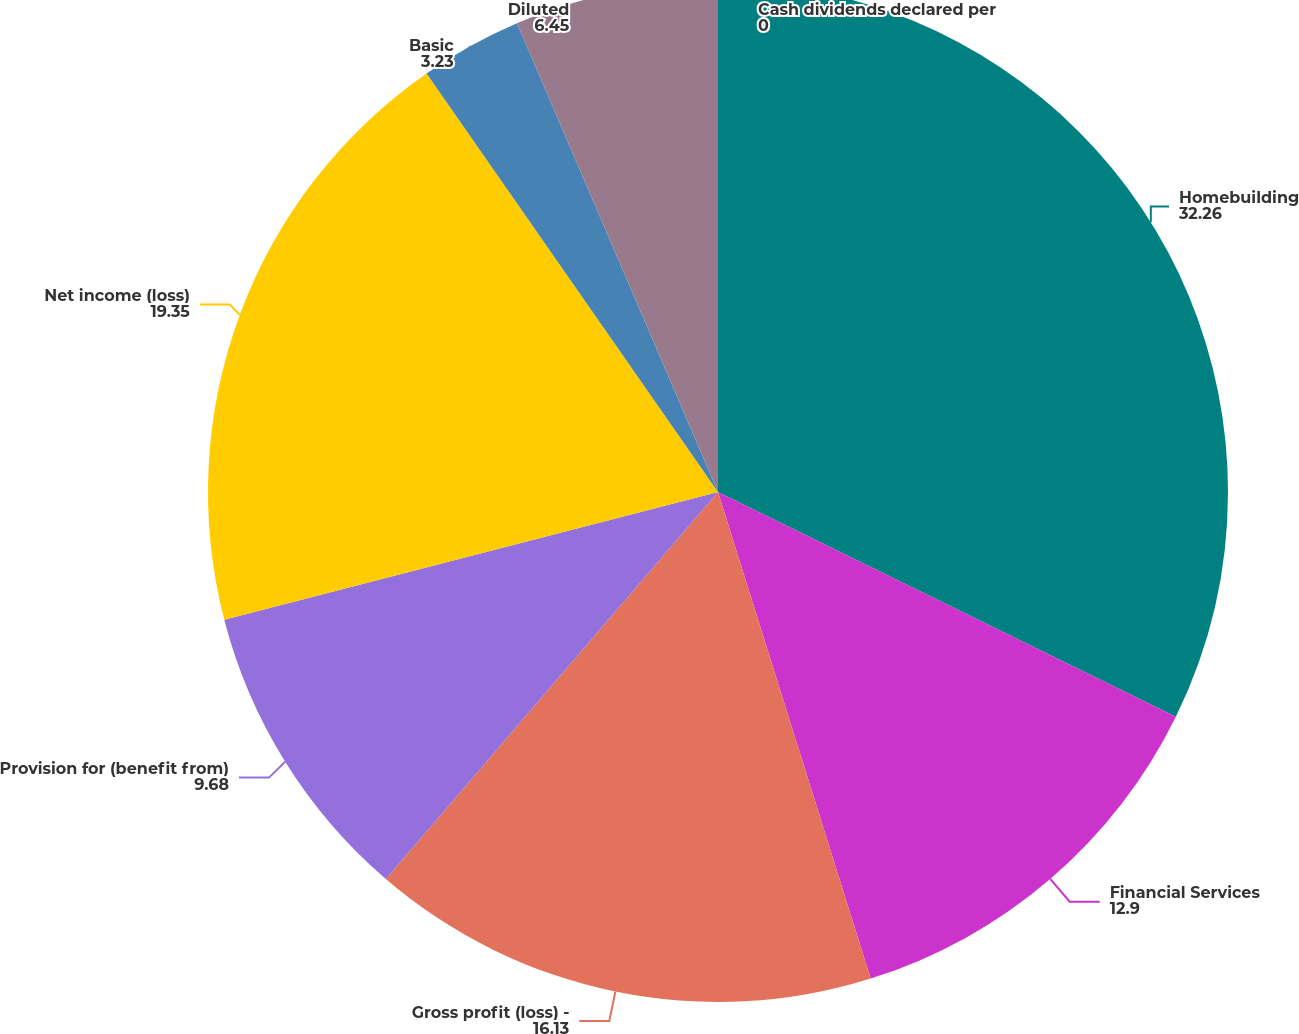Convert chart. <chart><loc_0><loc_0><loc_500><loc_500><pie_chart><fcel>Homebuilding<fcel>Financial Services<fcel>Gross profit (loss) -<fcel>Provision for (benefit from)<fcel>Net income (loss)<fcel>Basic<fcel>Diluted<fcel>Cash dividends declared per<nl><fcel>32.26%<fcel>12.9%<fcel>16.13%<fcel>9.68%<fcel>19.35%<fcel>3.23%<fcel>6.45%<fcel>0.0%<nl></chart> 